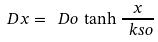<formula> <loc_0><loc_0><loc_500><loc_500>\ D x = \ D o \, \tanh \frac { x } { \ k s o }</formula> 